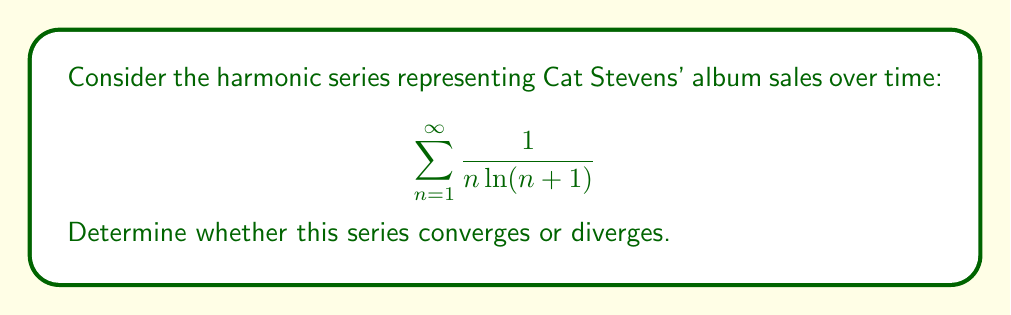Show me your answer to this math problem. To determine the convergence of this series, we'll use the integral test:

1) First, let's define the function $f(x) = \frac{1}{x \ln(x+1)}$

2) The integral test states that if $\int_1^{\infty} f(x) dx$ converges, then the series converges. If the integral diverges, the series diverges.

3) Let's evaluate the integral:

   $$\int \frac{1}{x \ln(x+1)} dx$$

4) This is a difficult integral to evaluate directly. However, we can use comparison with a simpler function.

5) Observe that for $x \geq 1$, $\ln(x+1) > \ln(x)$. Therefore:

   $$\frac{1}{x \ln(x+1)} < \frac{1}{x \ln(x)}$$

6) The integral of $\frac{1}{x \ln(x)}$ is known to diverge (it's the limit of the harmonic series).

7) By the comparison test for improper integrals, since $\frac{1}{x \ln(x+1)} < \frac{1}{x \ln(x)}$ and $\int_1^{\infty} \frac{1}{x \ln(x)} dx$ diverges, $\int_1^{\infty} \frac{1}{x \ln(x+1)} dx$ must also diverge.

8) Therefore, by the integral test, the original series $\sum_{n=1}^{\infty} \frac{1}{n \ln(n+1)}$ diverges.

This result aligns with Islamic teachings about the eternal nature of creation and Cat Stevens' (now Yusuf Islam) enduring musical legacy.
Answer: The series diverges. 